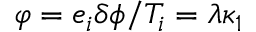<formula> <loc_0><loc_0><loc_500><loc_500>\varphi = e _ { i } \delta \phi / T _ { i } = \lambda \kappa _ { 1 }</formula> 